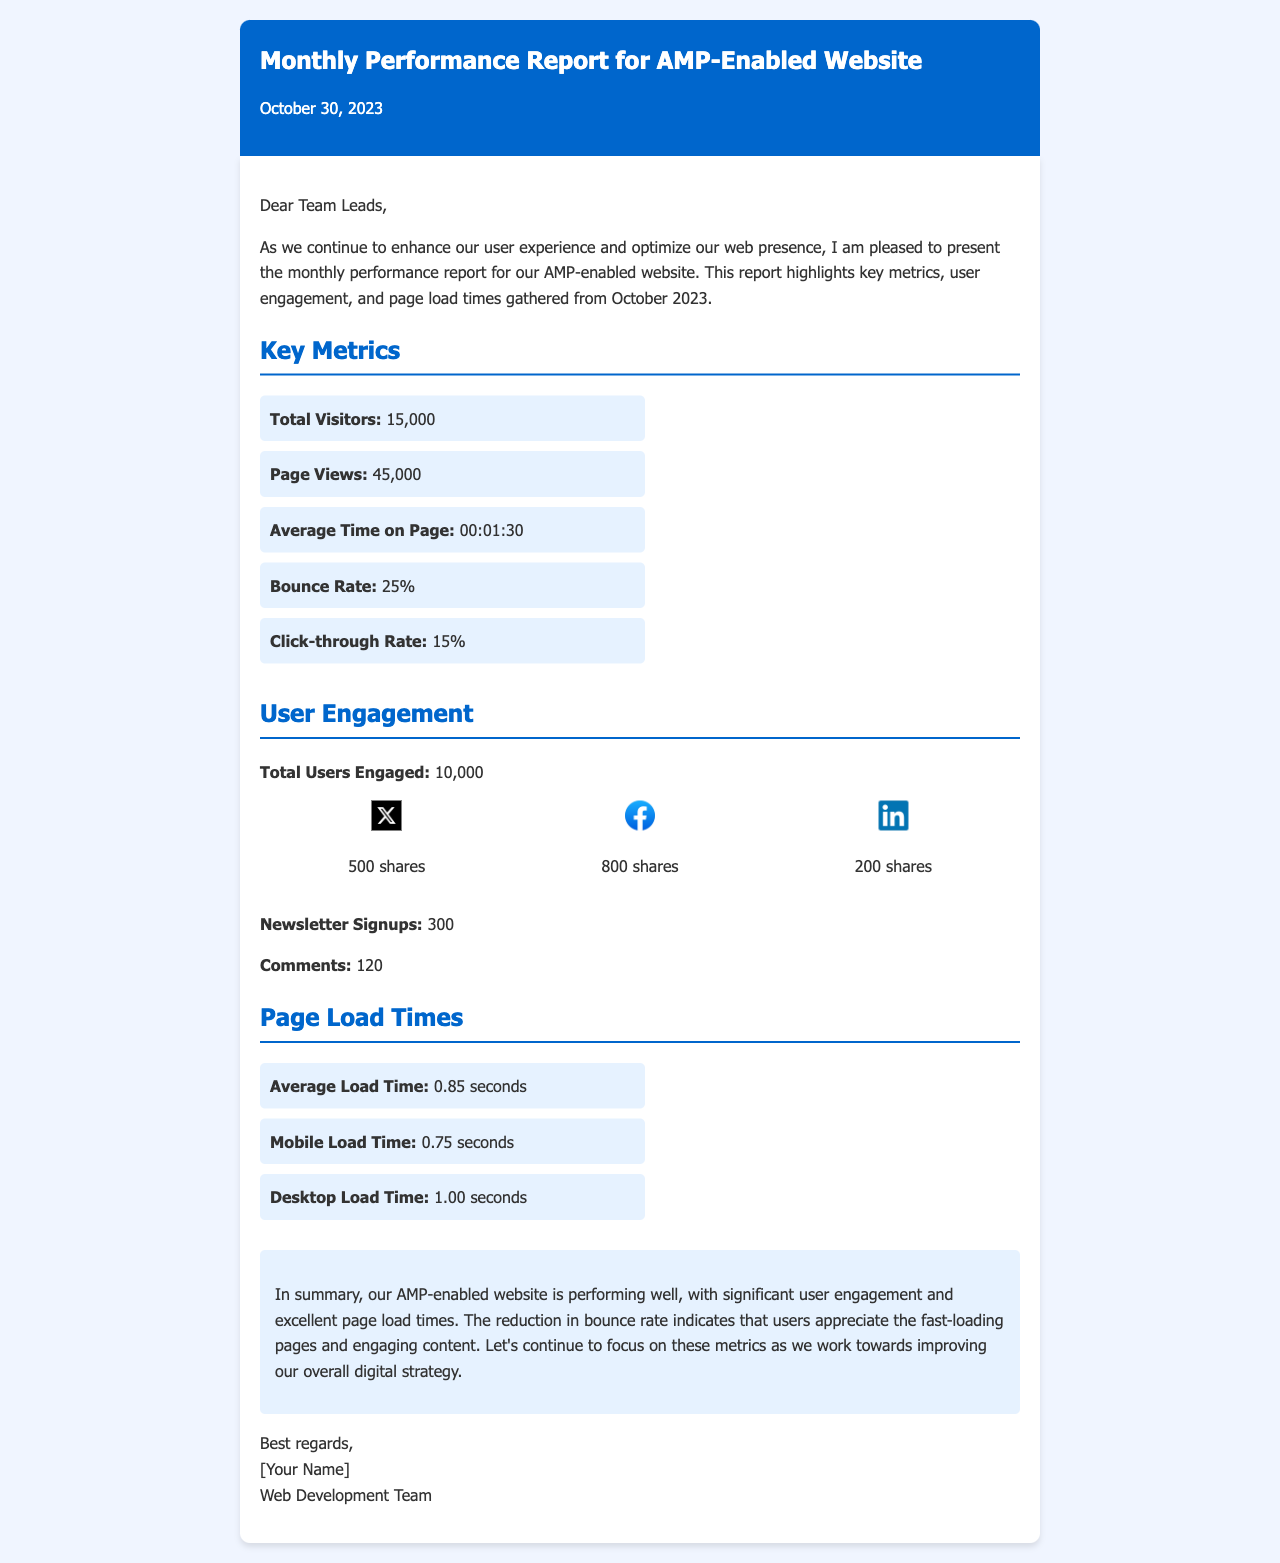What is the date of the report? The date of the report is clearly stated in the header of the document.
Answer: October 30, 2023 What is the total number of visitors? The document provides a specific metric for total visitors listed under Key Metrics.
Answer: 15,000 What is the average time on page? This information can be found in the Key Metrics section, which lists the average time users spend on the page.
Answer: 00:01:30 What is the bounce rate? The bounce rate metric is included in the Key Metrics to reflect user engagement.
Answer: 25% How many users engaged with the content? The number of users engaged is mentioned under the User Engagement section.
Answer: 10,000 What is the average load time for the website? The average load time is specified in the Page Load Times section as a key performance metric.
Answer: 0.85 seconds Which social platform had the highest number of shares? The document lists social shares from various platforms, helping to compare their performance directly.
Answer: Facebook What is the number of newsletter signups? The document specifies the total signups in the User Engagement section.
Answer: 300 What does the conclusion summarize about the website's performance? The conclusion provides an overall assessment of the performance based on the listed metrics.
Answer: Performing well 